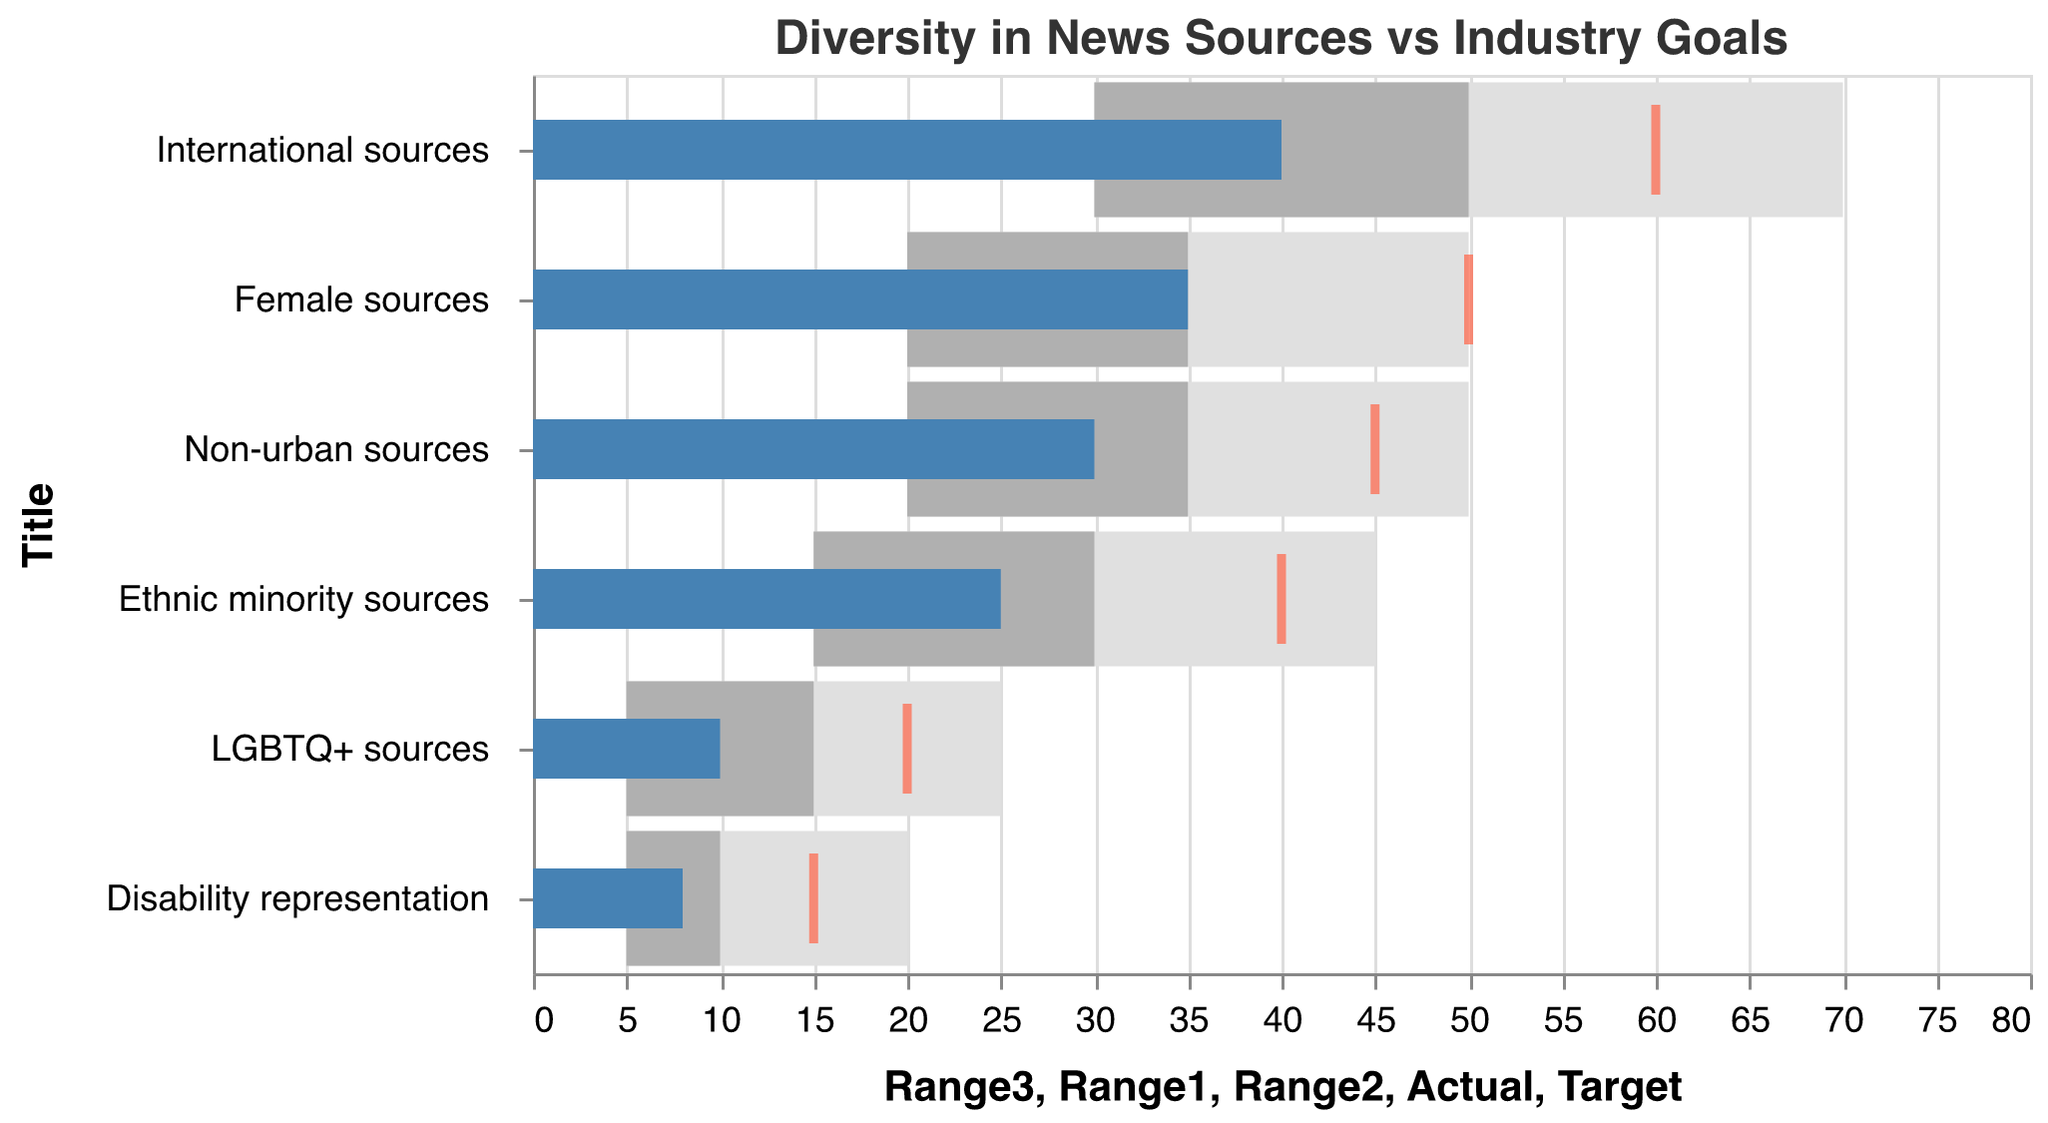What is the title of the chart? The chart title is usually located at the top of the figure and indicates the main topic or data being presented. In this case, it reads "Diversity in News Sources vs Industry Goals".
Answer: Diversity in News Sources vs Industry Goals What do the colored bars represent? In the bullet chart, the colored bars represent different ranges and the actual values. The light gray bars represent the lower range, the medium gray bars represent the middle range, and the dark blue bars represent the actual percentages achieved.
Answer: Different ranges and actual values Which category has the highest actual value? Each category's actual value is represented by a dark blue bar. By comparing the lengths of the dark blue bars, we can see that the "International sources" category has the longest bar, indicating the highest value.
Answer: International sources How far are the "Female sources" from their target value? The target value for "Female sources" is indicated by a red tick mark, and the actual value is represented by the dark blue bar. The target value is 50%, and the actual value is 35%. The difference is 50% - 35% = 15%.
Answer: 15% Which category has the smallest gap between the actual value and the target value? By examining the distance between the dark blue bars (actual values) and the red tick marks (targets) for each category, "LGBTQ+ sources" shows the smallest gap. The actual value is 10% while the target is 20%, creating a gap of 10%.
Answer: LGBTQ+ sources What is the range for "Disability representation"? The range values for "Disability representation" are represented by the lighter gray bars. The first range is from 5% to 10%, and the second range is from 10% to 20%.
Answer: 5% to 20% For "Non-urban sources," is the actual value within the target range? The actual value for "Non-urban sources" is represented by the dark blue bar, which is 30%. The target value is indicated by a red tick mark, which is 45%. The actual value falls within the middle range but does not reach the target.
Answer: No Compare the actual values of "Ethnic minority sources" and "LGBTQ+ sources." Which one is higher? Both categories' actual values are represented by dark blue bars. "Ethnic minority sources" has an actual value of 25%, whereas "LGBTQ+ sources" has an actual value of 10%.
Answer: Ethnic minority sources In which categories do the actual values fall below the lower range? The lower range is represented by the lightest gray bars. We need to identify the categories where the dark blue bars fall short of the lower end of these ranges: "Disability representation" is below its lower range of 5%-10%.
Answer: Disability representation 